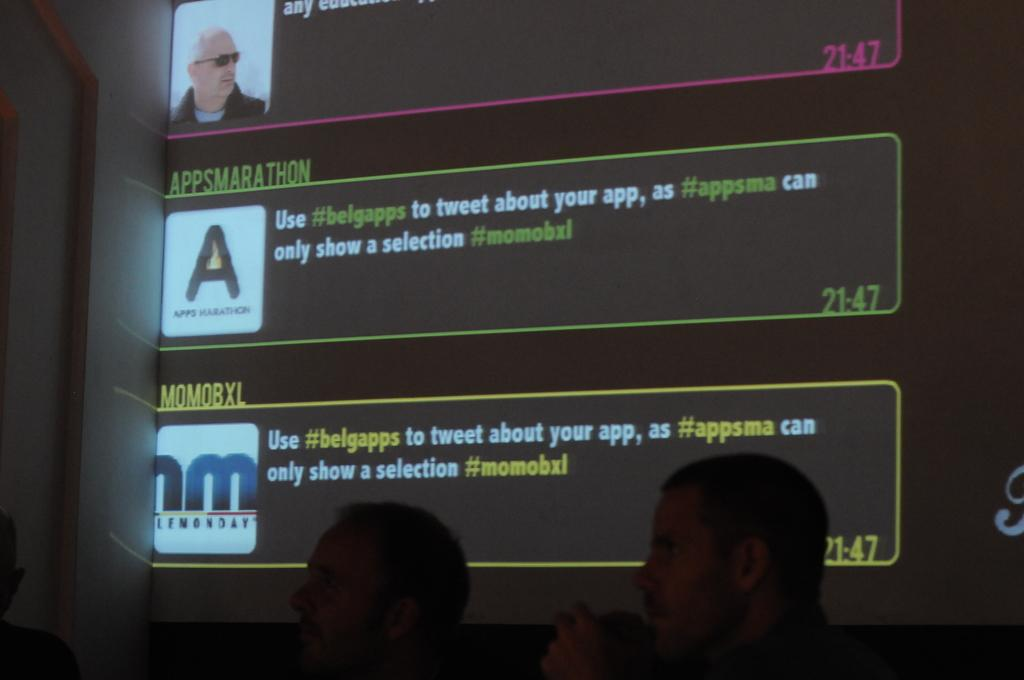What is the main object in the image? There is a screen in the image. What can be seen on the screen? Something is written on the screen. Are there any people visible in the image? Yes, there are people visible in the image. What type of brain is visible in the image? There is no brain visible in the image; it features a screen with written content and people. What kind of lunch is being served in the image? There is no lunch present in the image; it only shows a screen with written content and people. 